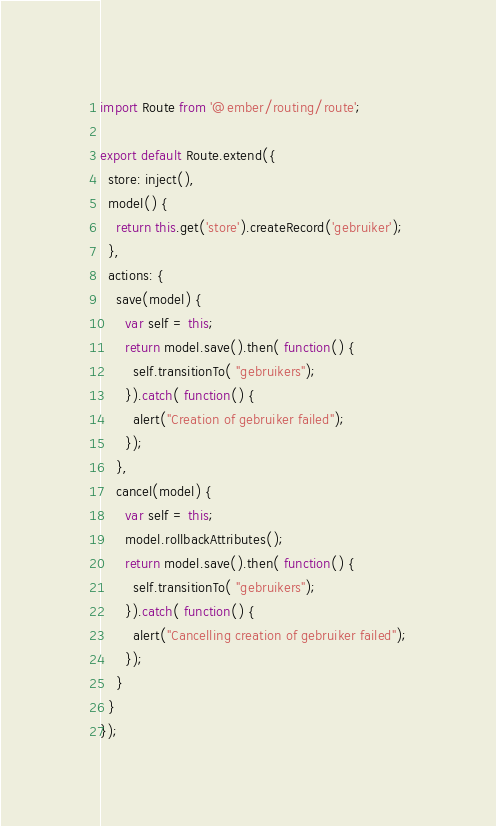Convert code to text. <code><loc_0><loc_0><loc_500><loc_500><_JavaScript_>import Route from '@ember/routing/route';

export default Route.extend({
  store: inject(),
  model() {
    return this.get('store').createRecord('gebruiker');
  },
  actions: {
    save(model) {
      var self = this;
      return model.save().then( function() {
        self.transitionTo( "gebruikers");
      }).catch( function() {
        alert("Creation of gebruiker failed");
      });
    },
    cancel(model) {
      var self = this;
      model.rollbackAttributes();
      return model.save().then( function() {
        self.transitionTo( "gebruikers");
      }).catch( function() {
        alert("Cancelling creation of gebruiker failed");
      });
    }
  }
});
</code> 